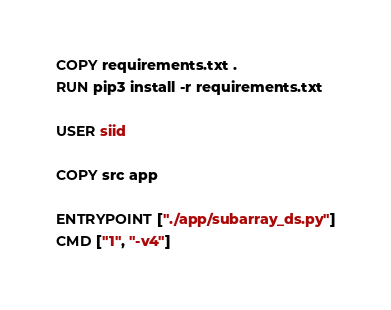Convert code to text. <code><loc_0><loc_0><loc_500><loc_500><_Dockerfile_>
COPY requirements.txt .
RUN pip3 install -r requirements.txt

USER siid

COPY src app

ENTRYPOINT ["./app/subarray_ds.py"]
CMD ["1", "-v4"]
</code> 